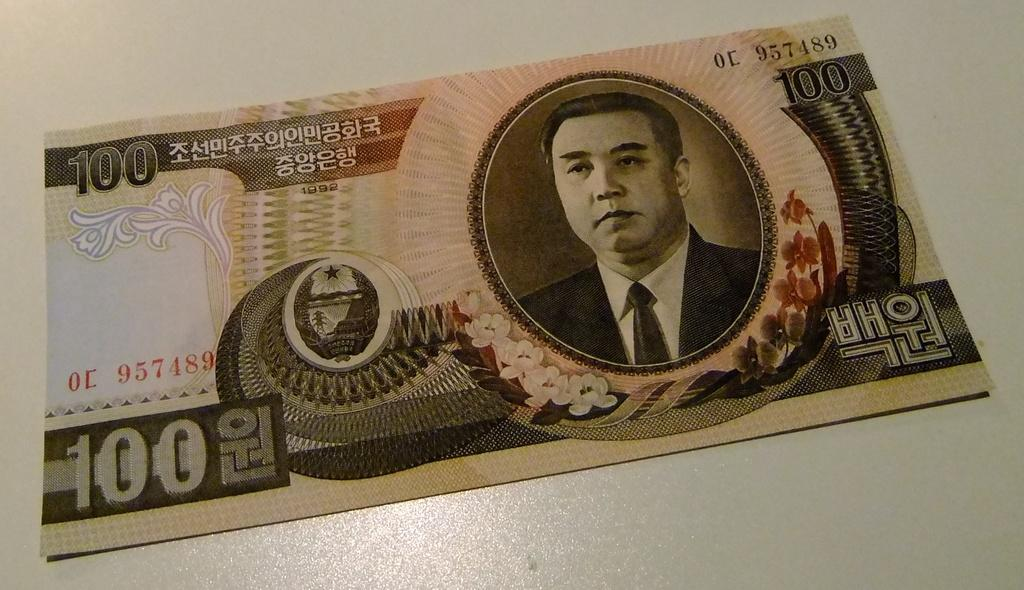Where was the image taken? The image was taken indoors. What can be seen at the bottom of the image? There is a table at the bottom of the image. Is there any additional information on the table? Yes, there is a note on the table. What type of arm is visible on the table in the image? There is no arm visible on the table in the image. How many deer are present in the image? There are no deer present in the image. 